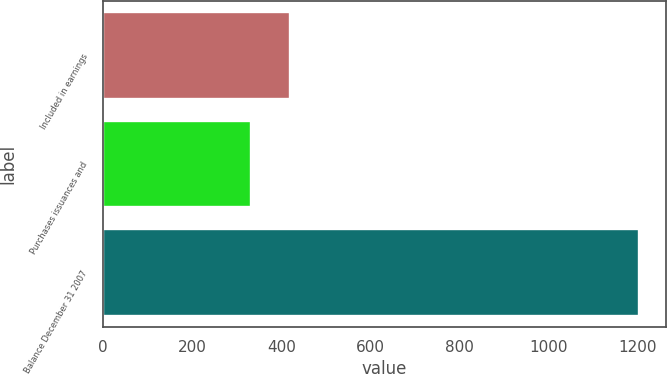Convert chart. <chart><loc_0><loc_0><loc_500><loc_500><bar_chart><fcel>Included in earnings<fcel>Purchases issuances and<fcel>Balance December 31 2007<nl><fcel>420<fcel>333<fcel>1203<nl></chart> 